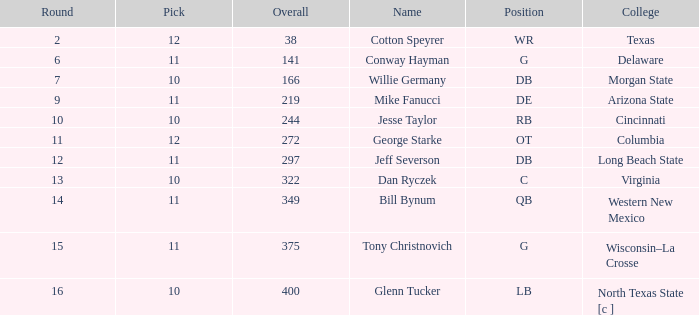What is the lowest round for an overall pick of 349 with a pick number in the round over 11? None. 